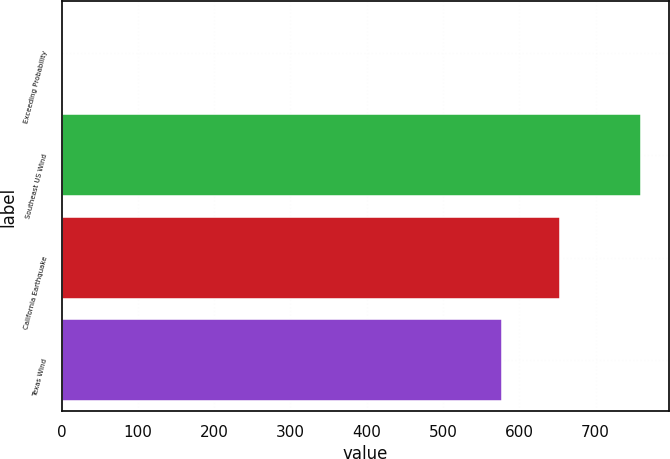Convert chart to OTSL. <chart><loc_0><loc_0><loc_500><loc_500><bar_chart><fcel>Exceeding Probability<fcel>Southeast US Wind<fcel>California Earthquake<fcel>Texas Wind<nl><fcel>1<fcel>759<fcel>653.8<fcel>578<nl></chart> 